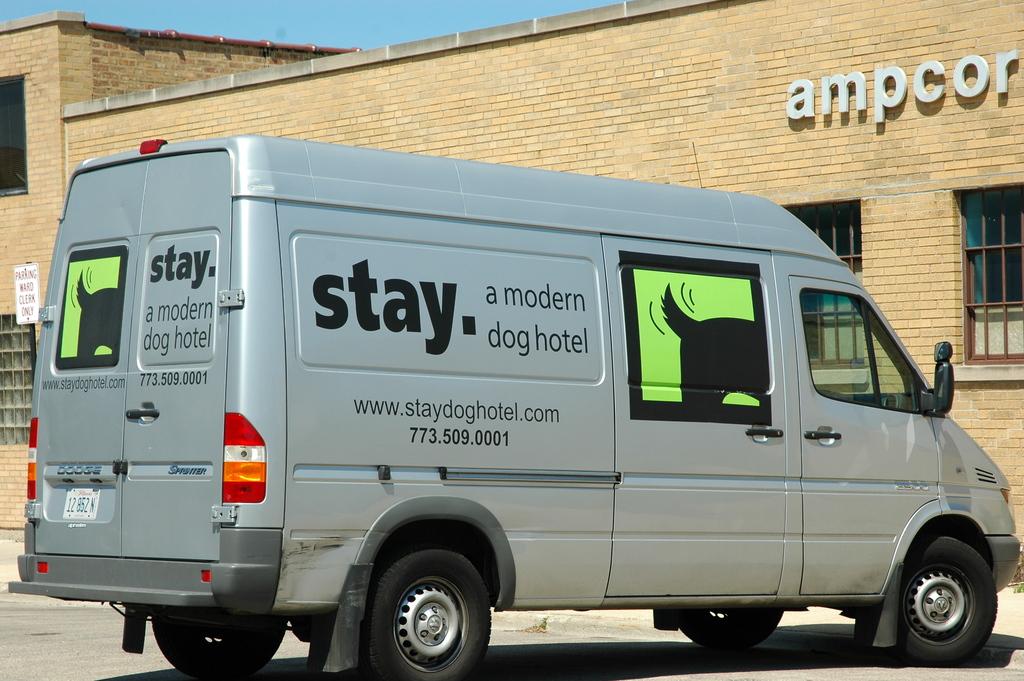What is the website on the van?
Give a very brief answer. Www.staydoghotel.com. What is the company name?
Your answer should be compact. Stay. 